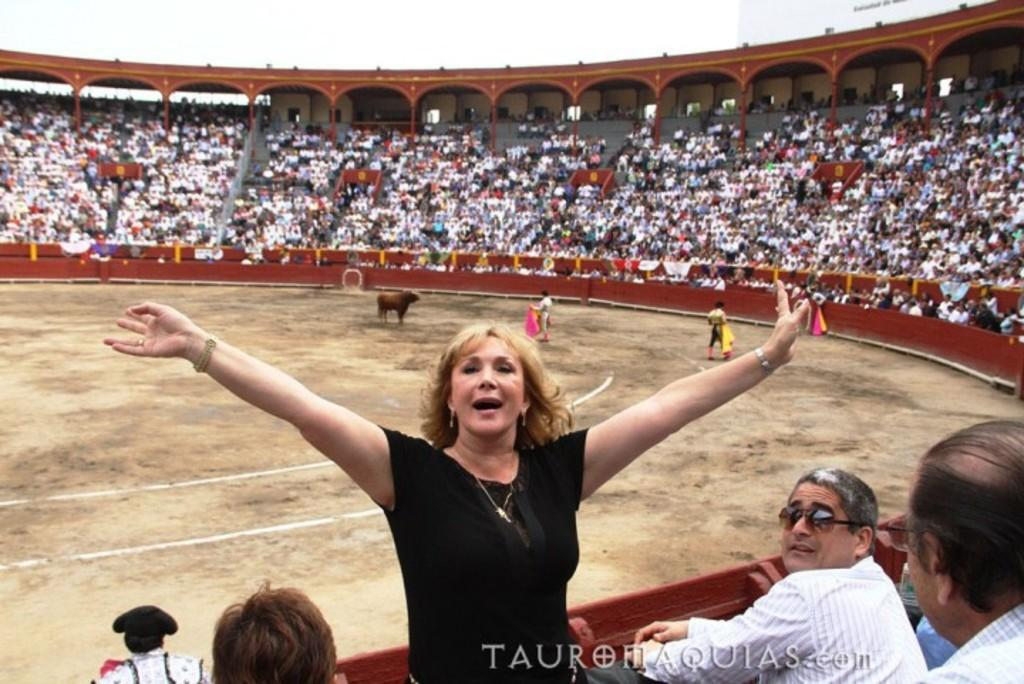What are the people in the image doing? The people in the image are sitting on chairs. Can you describe the woman in the image? There is a woman standing at the bottom of the image. What can be seen on the man's face in the image? The man in the image is wearing spectacles. What is visible in the background of the image? The sky is visible in the background of the image. What type of shop can be seen in the image? There is no shop present in the image. How does the woman's impulse affect the people sitting on chairs? The image does not provide information about the woman's impulses or how they might affect the people sitting on chairs. 